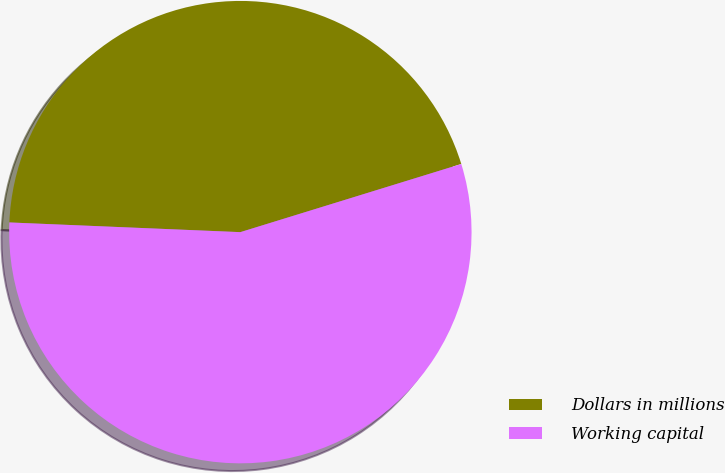<chart> <loc_0><loc_0><loc_500><loc_500><pie_chart><fcel>Dollars in millions<fcel>Working capital<nl><fcel>44.57%<fcel>55.43%<nl></chart> 